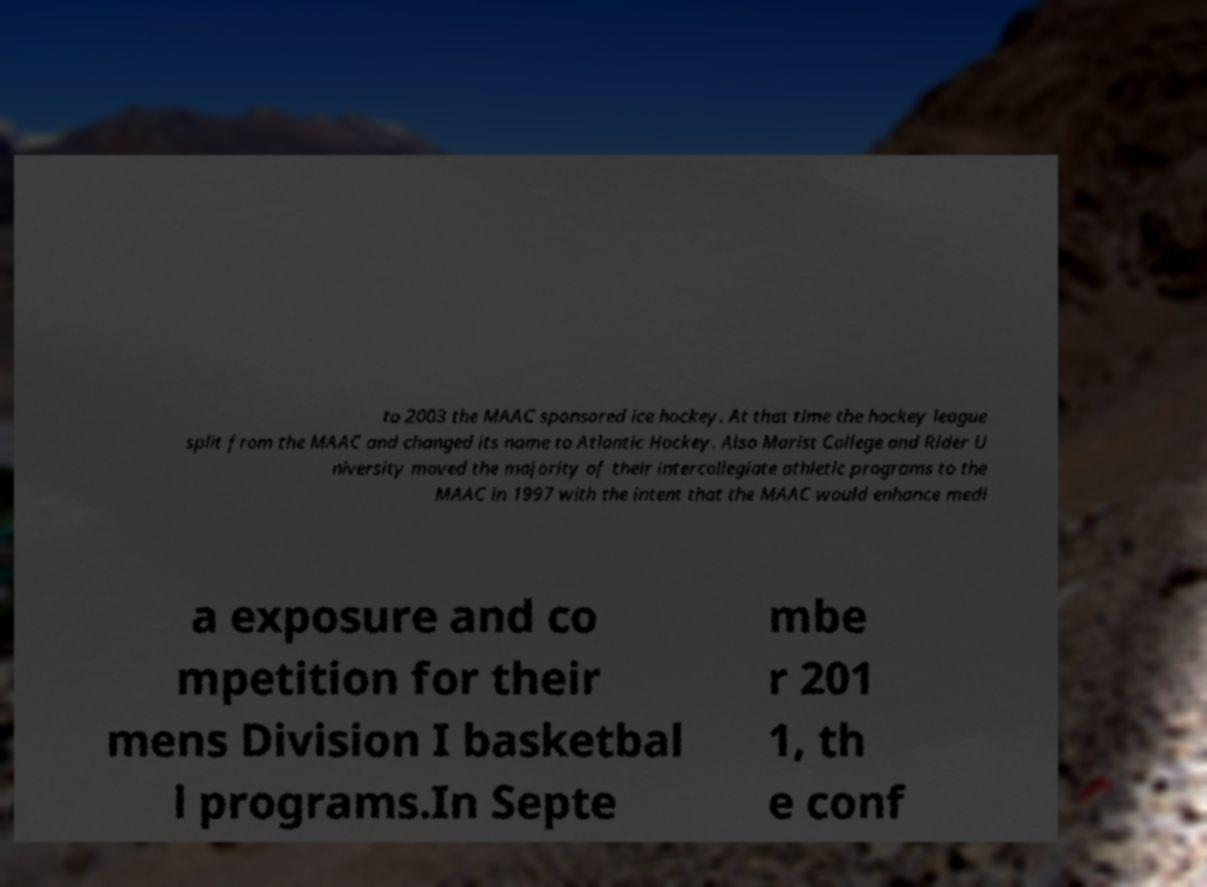There's text embedded in this image that I need extracted. Can you transcribe it verbatim? to 2003 the MAAC sponsored ice hockey. At that time the hockey league split from the MAAC and changed its name to Atlantic Hockey. Also Marist College and Rider U niversity moved the majority of their intercollegiate athletic programs to the MAAC in 1997 with the intent that the MAAC would enhance medi a exposure and co mpetition for their mens Division I basketbal l programs.In Septe mbe r 201 1, th e conf 